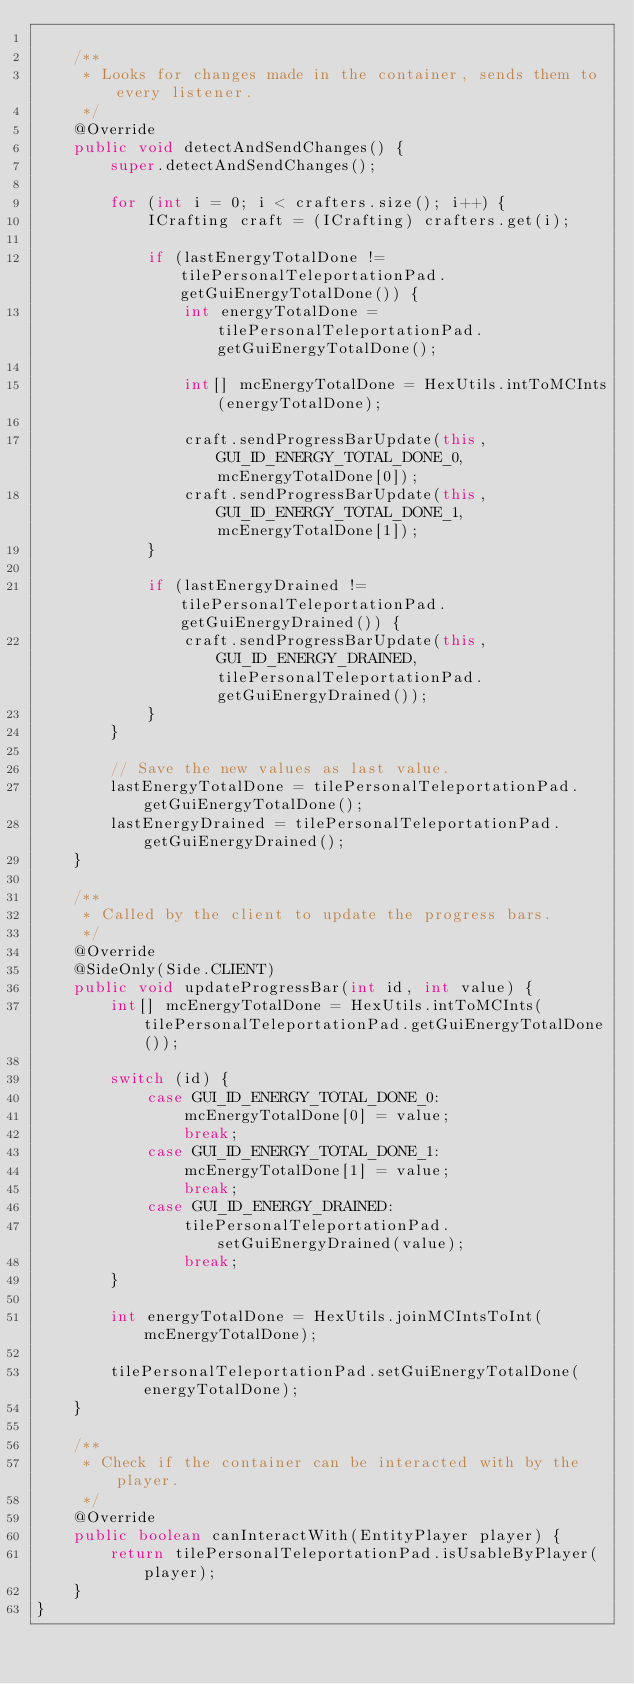<code> <loc_0><loc_0><loc_500><loc_500><_Java_>
    /**
     * Looks for changes made in the container, sends them to every listener.
     */
    @Override
    public void detectAndSendChanges() {
        super.detectAndSendChanges();

        for (int i = 0; i < crafters.size(); i++) {
            ICrafting craft = (ICrafting) crafters.get(i);

            if (lastEnergyTotalDone != tilePersonalTeleportationPad.getGuiEnergyTotalDone()) {
                int energyTotalDone = tilePersonalTeleportationPad.getGuiEnergyTotalDone();

                int[] mcEnergyTotalDone = HexUtils.intToMCInts(energyTotalDone);

                craft.sendProgressBarUpdate(this, GUI_ID_ENERGY_TOTAL_DONE_0, mcEnergyTotalDone[0]);
                craft.sendProgressBarUpdate(this, GUI_ID_ENERGY_TOTAL_DONE_1, mcEnergyTotalDone[1]);
            }

            if (lastEnergyDrained != tilePersonalTeleportationPad.getGuiEnergyDrained()) {
                craft.sendProgressBarUpdate(this, GUI_ID_ENERGY_DRAINED, tilePersonalTeleportationPad.getGuiEnergyDrained());
            }
        }

        // Save the new values as last value.
        lastEnergyTotalDone = tilePersonalTeleportationPad.getGuiEnergyTotalDone();
        lastEnergyDrained = tilePersonalTeleportationPad.getGuiEnergyDrained();
    }

    /**
     * Called by the client to update the progress bars.
     */
    @Override
    @SideOnly(Side.CLIENT)
    public void updateProgressBar(int id, int value) {
        int[] mcEnergyTotalDone = HexUtils.intToMCInts(tilePersonalTeleportationPad.getGuiEnergyTotalDone());

        switch (id) {
            case GUI_ID_ENERGY_TOTAL_DONE_0:
                mcEnergyTotalDone[0] = value;
                break;
            case GUI_ID_ENERGY_TOTAL_DONE_1:
                mcEnergyTotalDone[1] = value;
                break;
            case GUI_ID_ENERGY_DRAINED:
                tilePersonalTeleportationPad.setGuiEnergyDrained(value);
                break;
        }

        int energyTotalDone = HexUtils.joinMCIntsToInt(mcEnergyTotalDone);

        tilePersonalTeleportationPad.setGuiEnergyTotalDone(energyTotalDone);
    }

    /**
     * Check if the container can be interacted with by the player.
     */
    @Override
    public boolean canInteractWith(EntityPlayer player) {
        return tilePersonalTeleportationPad.isUsableByPlayer(player);
    }
}
</code> 